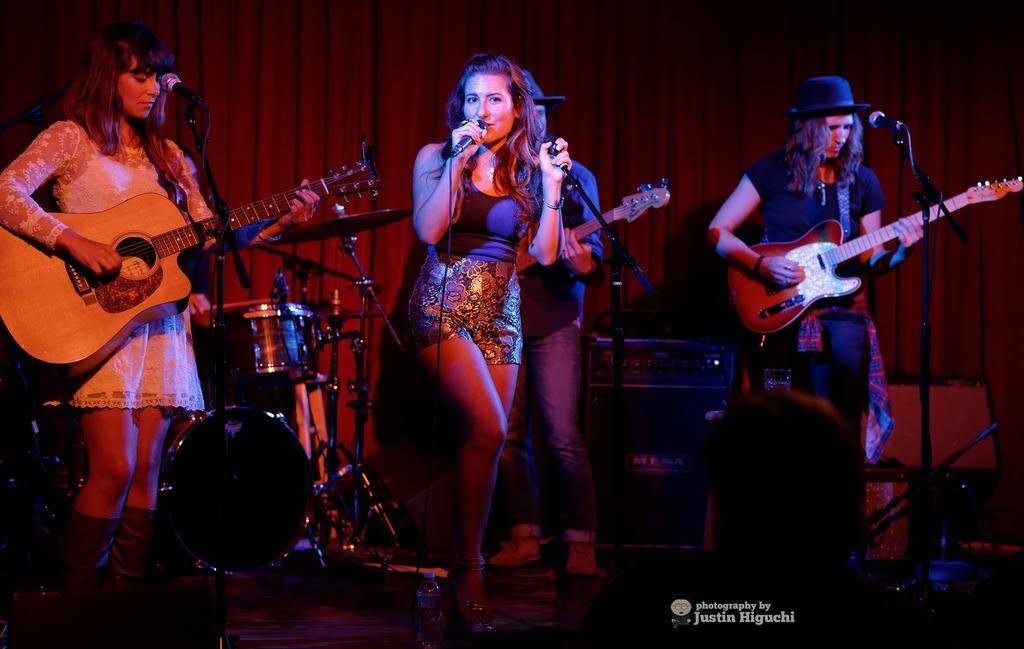Please provide a concise description of this image. This picture shows a woman standing and singing and other women on the left playing the guitar 